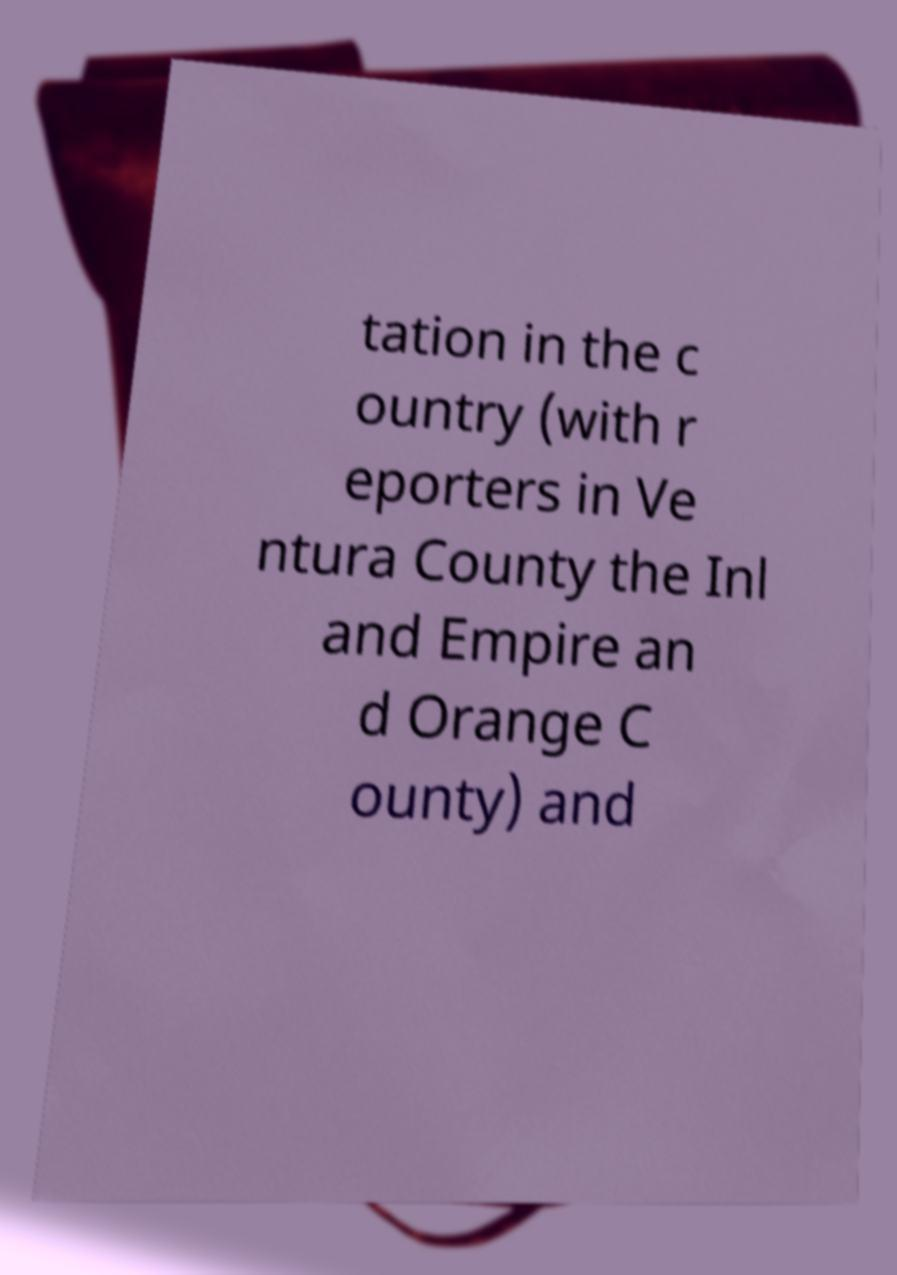What messages or text are displayed in this image? I need them in a readable, typed format. tation in the c ountry (with r eporters in Ve ntura County the Inl and Empire an d Orange C ounty) and 